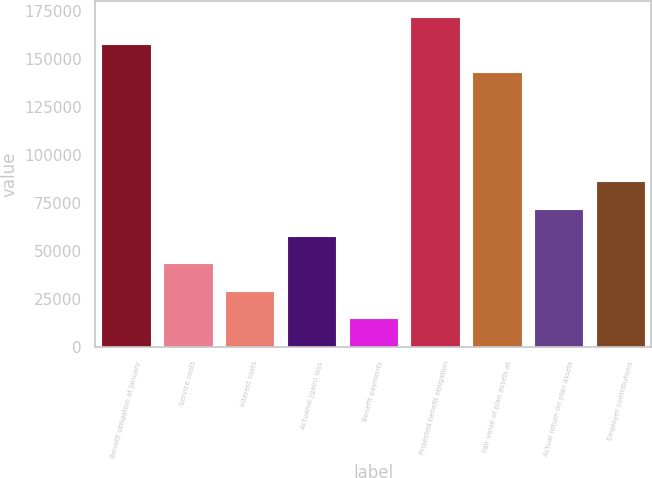Convert chart to OTSL. <chart><loc_0><loc_0><loc_500><loc_500><bar_chart><fcel>Benefit obligation at January<fcel>Service costs<fcel>Interest costs<fcel>Actuarial (gain) loss<fcel>Benefit payments<fcel>Projected benefit obligation<fcel>Fair value of plan assets at<fcel>Actual return on plan assets<fcel>Employer contributions<nl><fcel>157376<fcel>43629.9<fcel>29411.6<fcel>57848.2<fcel>15193.3<fcel>171595<fcel>143158<fcel>72066.5<fcel>86284.8<nl></chart> 